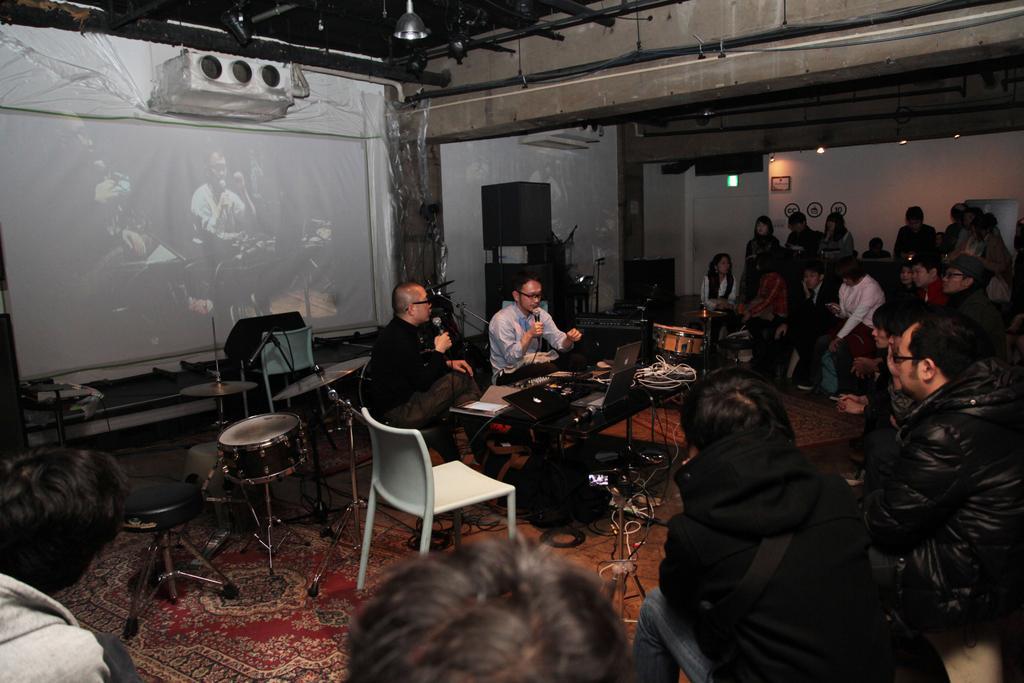In one or two sentences, can you explain what this image depicts? On the right side there are many people sitting and standing. In the middle two persons are sitting holding a mic. Also there is two other chairs. In front of them there is a table. On the table there are laptops, wires and books. Also there is a drum behind them. On the floor there is a carpet, bags and some other items. In the background there is a screen. Also there is a projector on the wall. On the wall there are pipes. 